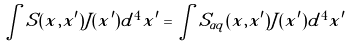Convert formula to latex. <formula><loc_0><loc_0><loc_500><loc_500>\int S ( x , x ^ { \prime } ) J ( x ^ { \prime } ) d ^ { 4 } x ^ { \prime } = \int S _ { \alpha q } ( x , x ^ { \prime } ) J ( x ^ { \prime } ) d ^ { 4 } x ^ { \prime }</formula> 